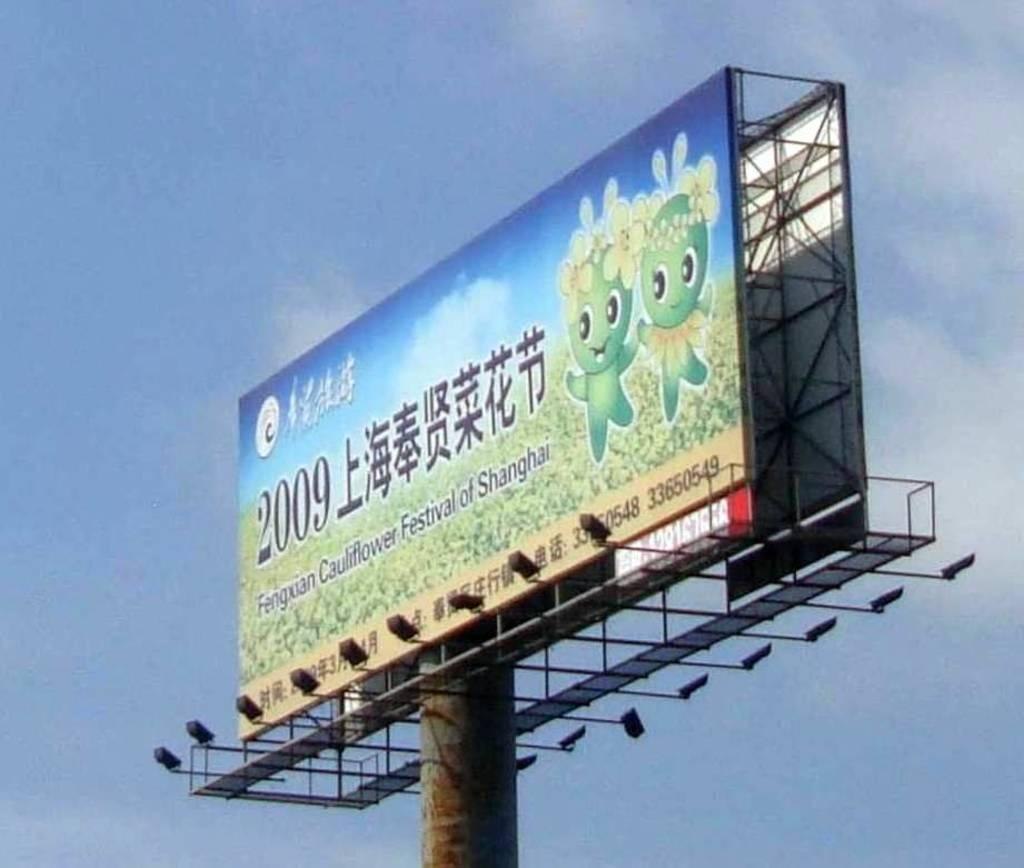Provide a one-sentence caption for the provided image. A billboard located in Asia advertising a Cauliflower Festival. 